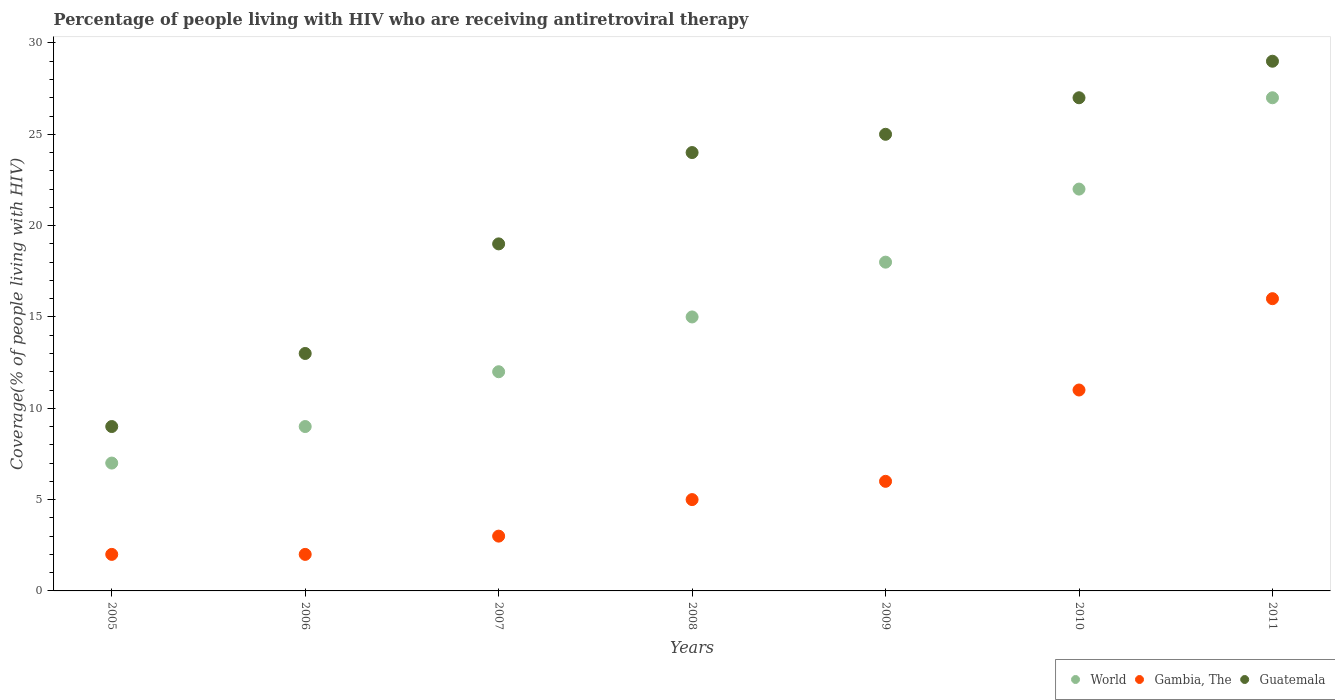How many different coloured dotlines are there?
Ensure brevity in your answer.  3. What is the percentage of the HIV infected people who are receiving antiretroviral therapy in Guatemala in 2011?
Your answer should be very brief. 29. Across all years, what is the maximum percentage of the HIV infected people who are receiving antiretroviral therapy in Gambia, The?
Give a very brief answer. 16. Across all years, what is the minimum percentage of the HIV infected people who are receiving antiretroviral therapy in Gambia, The?
Offer a very short reply. 2. What is the total percentage of the HIV infected people who are receiving antiretroviral therapy in Gambia, The in the graph?
Provide a succinct answer. 45. What is the difference between the percentage of the HIV infected people who are receiving antiretroviral therapy in Gambia, The in 2009 and that in 2011?
Offer a terse response. -10. What is the difference between the percentage of the HIV infected people who are receiving antiretroviral therapy in World in 2007 and the percentage of the HIV infected people who are receiving antiretroviral therapy in Guatemala in 2010?
Your response must be concise. -15. What is the average percentage of the HIV infected people who are receiving antiretroviral therapy in World per year?
Provide a succinct answer. 15.71. In the year 2009, what is the difference between the percentage of the HIV infected people who are receiving antiretroviral therapy in Gambia, The and percentage of the HIV infected people who are receiving antiretroviral therapy in Guatemala?
Offer a terse response. -19. Is the percentage of the HIV infected people who are receiving antiretroviral therapy in Guatemala in 2005 less than that in 2006?
Your answer should be very brief. Yes. What is the difference between the highest and the second highest percentage of the HIV infected people who are receiving antiretroviral therapy in World?
Provide a short and direct response. 5. What is the difference between the highest and the lowest percentage of the HIV infected people who are receiving antiretroviral therapy in World?
Offer a terse response. 20. In how many years, is the percentage of the HIV infected people who are receiving antiretroviral therapy in World greater than the average percentage of the HIV infected people who are receiving antiretroviral therapy in World taken over all years?
Provide a short and direct response. 3. How many dotlines are there?
Give a very brief answer. 3. What is the difference between two consecutive major ticks on the Y-axis?
Your response must be concise. 5. Does the graph contain any zero values?
Your answer should be compact. No. Does the graph contain grids?
Your response must be concise. No. Where does the legend appear in the graph?
Offer a terse response. Bottom right. What is the title of the graph?
Your response must be concise. Percentage of people living with HIV who are receiving antiretroviral therapy. What is the label or title of the Y-axis?
Offer a terse response. Coverage(% of people living with HIV). What is the Coverage(% of people living with HIV) in Gambia, The in 2005?
Give a very brief answer. 2. What is the Coverage(% of people living with HIV) in World in 2007?
Offer a terse response. 12. What is the Coverage(% of people living with HIV) in Gambia, The in 2007?
Provide a short and direct response. 3. What is the Coverage(% of people living with HIV) of Gambia, The in 2008?
Keep it short and to the point. 5. What is the Coverage(% of people living with HIV) of Gambia, The in 2009?
Provide a succinct answer. 6. What is the Coverage(% of people living with HIV) in Guatemala in 2009?
Your answer should be compact. 25. What is the Coverage(% of people living with HIV) of World in 2011?
Ensure brevity in your answer.  27. What is the Coverage(% of people living with HIV) of Guatemala in 2011?
Keep it short and to the point. 29. Across all years, what is the maximum Coverage(% of people living with HIV) in World?
Your answer should be very brief. 27. Across all years, what is the minimum Coverage(% of people living with HIV) in World?
Make the answer very short. 7. What is the total Coverage(% of people living with HIV) of World in the graph?
Make the answer very short. 110. What is the total Coverage(% of people living with HIV) of Gambia, The in the graph?
Give a very brief answer. 45. What is the total Coverage(% of people living with HIV) in Guatemala in the graph?
Your response must be concise. 146. What is the difference between the Coverage(% of people living with HIV) of Guatemala in 2005 and that in 2007?
Offer a very short reply. -10. What is the difference between the Coverage(% of people living with HIV) of World in 2005 and that in 2008?
Ensure brevity in your answer.  -8. What is the difference between the Coverage(% of people living with HIV) of Guatemala in 2005 and that in 2008?
Ensure brevity in your answer.  -15. What is the difference between the Coverage(% of people living with HIV) in World in 2005 and that in 2009?
Provide a short and direct response. -11. What is the difference between the Coverage(% of people living with HIV) of Gambia, The in 2005 and that in 2009?
Ensure brevity in your answer.  -4. What is the difference between the Coverage(% of people living with HIV) in Guatemala in 2005 and that in 2009?
Your answer should be very brief. -16. What is the difference between the Coverage(% of people living with HIV) in Guatemala in 2005 and that in 2011?
Your response must be concise. -20. What is the difference between the Coverage(% of people living with HIV) in Gambia, The in 2006 and that in 2007?
Your response must be concise. -1. What is the difference between the Coverage(% of people living with HIV) in Guatemala in 2006 and that in 2007?
Make the answer very short. -6. What is the difference between the Coverage(% of people living with HIV) in World in 2006 and that in 2008?
Keep it short and to the point. -6. What is the difference between the Coverage(% of people living with HIV) of Gambia, The in 2006 and that in 2008?
Offer a very short reply. -3. What is the difference between the Coverage(% of people living with HIV) in World in 2006 and that in 2009?
Provide a short and direct response. -9. What is the difference between the Coverage(% of people living with HIV) of Gambia, The in 2006 and that in 2009?
Make the answer very short. -4. What is the difference between the Coverage(% of people living with HIV) of Gambia, The in 2006 and that in 2010?
Your answer should be very brief. -9. What is the difference between the Coverage(% of people living with HIV) in Guatemala in 2006 and that in 2010?
Keep it short and to the point. -14. What is the difference between the Coverage(% of people living with HIV) in Guatemala in 2007 and that in 2008?
Ensure brevity in your answer.  -5. What is the difference between the Coverage(% of people living with HIV) in Gambia, The in 2007 and that in 2009?
Provide a succinct answer. -3. What is the difference between the Coverage(% of people living with HIV) in Guatemala in 2007 and that in 2009?
Offer a terse response. -6. What is the difference between the Coverage(% of people living with HIV) in Gambia, The in 2007 and that in 2010?
Your answer should be very brief. -8. What is the difference between the Coverage(% of people living with HIV) in World in 2007 and that in 2011?
Provide a short and direct response. -15. What is the difference between the Coverage(% of people living with HIV) in World in 2008 and that in 2010?
Offer a very short reply. -7. What is the difference between the Coverage(% of people living with HIV) of Gambia, The in 2008 and that in 2010?
Give a very brief answer. -6. What is the difference between the Coverage(% of people living with HIV) in Guatemala in 2008 and that in 2010?
Give a very brief answer. -3. What is the difference between the Coverage(% of people living with HIV) of Gambia, The in 2009 and that in 2010?
Give a very brief answer. -5. What is the difference between the Coverage(% of people living with HIV) of Guatemala in 2009 and that in 2010?
Give a very brief answer. -2. What is the difference between the Coverage(% of people living with HIV) of World in 2010 and that in 2011?
Offer a very short reply. -5. What is the difference between the Coverage(% of people living with HIV) of World in 2005 and the Coverage(% of people living with HIV) of Gambia, The in 2006?
Offer a terse response. 5. What is the difference between the Coverage(% of people living with HIV) in Gambia, The in 2005 and the Coverage(% of people living with HIV) in Guatemala in 2006?
Make the answer very short. -11. What is the difference between the Coverage(% of people living with HIV) in World in 2005 and the Coverage(% of people living with HIV) in Guatemala in 2007?
Offer a terse response. -12. What is the difference between the Coverage(% of people living with HIV) in Gambia, The in 2005 and the Coverage(% of people living with HIV) in Guatemala in 2007?
Make the answer very short. -17. What is the difference between the Coverage(% of people living with HIV) in World in 2005 and the Coverage(% of people living with HIV) in Gambia, The in 2008?
Keep it short and to the point. 2. What is the difference between the Coverage(% of people living with HIV) in World in 2005 and the Coverage(% of people living with HIV) in Gambia, The in 2009?
Your answer should be compact. 1. What is the difference between the Coverage(% of people living with HIV) of World in 2005 and the Coverage(% of people living with HIV) of Guatemala in 2009?
Your answer should be compact. -18. What is the difference between the Coverage(% of people living with HIV) of Gambia, The in 2005 and the Coverage(% of people living with HIV) of Guatemala in 2009?
Provide a short and direct response. -23. What is the difference between the Coverage(% of people living with HIV) in World in 2005 and the Coverage(% of people living with HIV) in Guatemala in 2010?
Your response must be concise. -20. What is the difference between the Coverage(% of people living with HIV) in World in 2005 and the Coverage(% of people living with HIV) in Gambia, The in 2011?
Your response must be concise. -9. What is the difference between the Coverage(% of people living with HIV) in World in 2005 and the Coverage(% of people living with HIV) in Guatemala in 2011?
Offer a very short reply. -22. What is the difference between the Coverage(% of people living with HIV) in World in 2006 and the Coverage(% of people living with HIV) in Gambia, The in 2007?
Your answer should be compact. 6. What is the difference between the Coverage(% of people living with HIV) in World in 2006 and the Coverage(% of people living with HIV) in Guatemala in 2007?
Give a very brief answer. -10. What is the difference between the Coverage(% of people living with HIV) in Gambia, The in 2006 and the Coverage(% of people living with HIV) in Guatemala in 2008?
Give a very brief answer. -22. What is the difference between the Coverage(% of people living with HIV) in World in 2006 and the Coverage(% of people living with HIV) in Guatemala in 2009?
Your answer should be compact. -16. What is the difference between the Coverage(% of people living with HIV) of World in 2006 and the Coverage(% of people living with HIV) of Gambia, The in 2010?
Offer a terse response. -2. What is the difference between the Coverage(% of people living with HIV) of World in 2006 and the Coverage(% of people living with HIV) of Gambia, The in 2011?
Ensure brevity in your answer.  -7. What is the difference between the Coverage(% of people living with HIV) of World in 2006 and the Coverage(% of people living with HIV) of Guatemala in 2011?
Your answer should be compact. -20. What is the difference between the Coverage(% of people living with HIV) of Gambia, The in 2006 and the Coverage(% of people living with HIV) of Guatemala in 2011?
Make the answer very short. -27. What is the difference between the Coverage(% of people living with HIV) of World in 2007 and the Coverage(% of people living with HIV) of Gambia, The in 2008?
Give a very brief answer. 7. What is the difference between the Coverage(% of people living with HIV) in World in 2007 and the Coverage(% of people living with HIV) in Guatemala in 2008?
Your answer should be compact. -12. What is the difference between the Coverage(% of people living with HIV) in World in 2007 and the Coverage(% of people living with HIV) in Gambia, The in 2009?
Ensure brevity in your answer.  6. What is the difference between the Coverage(% of people living with HIV) of World in 2007 and the Coverage(% of people living with HIV) of Guatemala in 2010?
Provide a short and direct response. -15. What is the difference between the Coverage(% of people living with HIV) in Gambia, The in 2007 and the Coverage(% of people living with HIV) in Guatemala in 2010?
Your response must be concise. -24. What is the difference between the Coverage(% of people living with HIV) of World in 2007 and the Coverage(% of people living with HIV) of Gambia, The in 2011?
Provide a succinct answer. -4. What is the difference between the Coverage(% of people living with HIV) in World in 2007 and the Coverage(% of people living with HIV) in Guatemala in 2011?
Offer a terse response. -17. What is the difference between the Coverage(% of people living with HIV) in World in 2008 and the Coverage(% of people living with HIV) in Guatemala in 2009?
Offer a terse response. -10. What is the difference between the Coverage(% of people living with HIV) in Gambia, The in 2008 and the Coverage(% of people living with HIV) in Guatemala in 2009?
Your answer should be compact. -20. What is the difference between the Coverage(% of people living with HIV) of World in 2008 and the Coverage(% of people living with HIV) of Gambia, The in 2010?
Make the answer very short. 4. What is the difference between the Coverage(% of people living with HIV) in World in 2008 and the Coverage(% of people living with HIV) in Guatemala in 2010?
Keep it short and to the point. -12. What is the difference between the Coverage(% of people living with HIV) in Gambia, The in 2008 and the Coverage(% of people living with HIV) in Guatemala in 2010?
Make the answer very short. -22. What is the difference between the Coverage(% of people living with HIV) of World in 2008 and the Coverage(% of people living with HIV) of Gambia, The in 2011?
Keep it short and to the point. -1. What is the difference between the Coverage(% of people living with HIV) in Gambia, The in 2008 and the Coverage(% of people living with HIV) in Guatemala in 2011?
Your answer should be very brief. -24. What is the difference between the Coverage(% of people living with HIV) in World in 2009 and the Coverage(% of people living with HIV) in Gambia, The in 2010?
Offer a terse response. 7. What is the difference between the Coverage(% of people living with HIV) in World in 2009 and the Coverage(% of people living with HIV) in Guatemala in 2010?
Provide a succinct answer. -9. What is the difference between the Coverage(% of people living with HIV) of World in 2009 and the Coverage(% of people living with HIV) of Guatemala in 2011?
Your answer should be compact. -11. What is the difference between the Coverage(% of people living with HIV) of Gambia, The in 2009 and the Coverage(% of people living with HIV) of Guatemala in 2011?
Ensure brevity in your answer.  -23. What is the difference between the Coverage(% of people living with HIV) of World in 2010 and the Coverage(% of people living with HIV) of Guatemala in 2011?
Offer a terse response. -7. What is the difference between the Coverage(% of people living with HIV) in Gambia, The in 2010 and the Coverage(% of people living with HIV) in Guatemala in 2011?
Your response must be concise. -18. What is the average Coverage(% of people living with HIV) of World per year?
Your answer should be very brief. 15.71. What is the average Coverage(% of people living with HIV) of Gambia, The per year?
Your answer should be very brief. 6.43. What is the average Coverage(% of people living with HIV) in Guatemala per year?
Your answer should be very brief. 20.86. In the year 2005, what is the difference between the Coverage(% of people living with HIV) in World and Coverage(% of people living with HIV) in Guatemala?
Give a very brief answer. -2. In the year 2006, what is the difference between the Coverage(% of people living with HIV) of World and Coverage(% of people living with HIV) of Gambia, The?
Make the answer very short. 7. In the year 2006, what is the difference between the Coverage(% of people living with HIV) in World and Coverage(% of people living with HIV) in Guatemala?
Your response must be concise. -4. In the year 2007, what is the difference between the Coverage(% of people living with HIV) of World and Coverage(% of people living with HIV) of Guatemala?
Your response must be concise. -7. In the year 2007, what is the difference between the Coverage(% of people living with HIV) in Gambia, The and Coverage(% of people living with HIV) in Guatemala?
Give a very brief answer. -16. In the year 2008, what is the difference between the Coverage(% of people living with HIV) in Gambia, The and Coverage(% of people living with HIV) in Guatemala?
Provide a succinct answer. -19. In the year 2009, what is the difference between the Coverage(% of people living with HIV) of World and Coverage(% of people living with HIV) of Guatemala?
Ensure brevity in your answer.  -7. In the year 2009, what is the difference between the Coverage(% of people living with HIV) in Gambia, The and Coverage(% of people living with HIV) in Guatemala?
Offer a very short reply. -19. In the year 2010, what is the difference between the Coverage(% of people living with HIV) in Gambia, The and Coverage(% of people living with HIV) in Guatemala?
Your response must be concise. -16. In the year 2011, what is the difference between the Coverage(% of people living with HIV) of World and Coverage(% of people living with HIV) of Guatemala?
Your answer should be compact. -2. What is the ratio of the Coverage(% of people living with HIV) of Guatemala in 2005 to that in 2006?
Provide a succinct answer. 0.69. What is the ratio of the Coverage(% of people living with HIV) in World in 2005 to that in 2007?
Your answer should be compact. 0.58. What is the ratio of the Coverage(% of people living with HIV) of Guatemala in 2005 to that in 2007?
Your answer should be compact. 0.47. What is the ratio of the Coverage(% of people living with HIV) of World in 2005 to that in 2008?
Your answer should be compact. 0.47. What is the ratio of the Coverage(% of people living with HIV) in Gambia, The in 2005 to that in 2008?
Offer a very short reply. 0.4. What is the ratio of the Coverage(% of people living with HIV) of Guatemala in 2005 to that in 2008?
Make the answer very short. 0.38. What is the ratio of the Coverage(% of people living with HIV) in World in 2005 to that in 2009?
Give a very brief answer. 0.39. What is the ratio of the Coverage(% of people living with HIV) of Gambia, The in 2005 to that in 2009?
Offer a very short reply. 0.33. What is the ratio of the Coverage(% of people living with HIV) of Guatemala in 2005 to that in 2009?
Your answer should be very brief. 0.36. What is the ratio of the Coverage(% of people living with HIV) in World in 2005 to that in 2010?
Your answer should be very brief. 0.32. What is the ratio of the Coverage(% of people living with HIV) in Gambia, The in 2005 to that in 2010?
Give a very brief answer. 0.18. What is the ratio of the Coverage(% of people living with HIV) in World in 2005 to that in 2011?
Provide a short and direct response. 0.26. What is the ratio of the Coverage(% of people living with HIV) of Gambia, The in 2005 to that in 2011?
Your answer should be compact. 0.12. What is the ratio of the Coverage(% of people living with HIV) of Guatemala in 2005 to that in 2011?
Keep it short and to the point. 0.31. What is the ratio of the Coverage(% of people living with HIV) of World in 2006 to that in 2007?
Your answer should be very brief. 0.75. What is the ratio of the Coverage(% of people living with HIV) in Guatemala in 2006 to that in 2007?
Your response must be concise. 0.68. What is the ratio of the Coverage(% of people living with HIV) in World in 2006 to that in 2008?
Give a very brief answer. 0.6. What is the ratio of the Coverage(% of people living with HIV) in Gambia, The in 2006 to that in 2008?
Offer a very short reply. 0.4. What is the ratio of the Coverage(% of people living with HIV) in Guatemala in 2006 to that in 2008?
Offer a very short reply. 0.54. What is the ratio of the Coverage(% of people living with HIV) in Gambia, The in 2006 to that in 2009?
Provide a succinct answer. 0.33. What is the ratio of the Coverage(% of people living with HIV) in Guatemala in 2006 to that in 2009?
Offer a very short reply. 0.52. What is the ratio of the Coverage(% of people living with HIV) in World in 2006 to that in 2010?
Offer a very short reply. 0.41. What is the ratio of the Coverage(% of people living with HIV) of Gambia, The in 2006 to that in 2010?
Your response must be concise. 0.18. What is the ratio of the Coverage(% of people living with HIV) in Guatemala in 2006 to that in 2010?
Offer a very short reply. 0.48. What is the ratio of the Coverage(% of people living with HIV) in World in 2006 to that in 2011?
Give a very brief answer. 0.33. What is the ratio of the Coverage(% of people living with HIV) of Gambia, The in 2006 to that in 2011?
Make the answer very short. 0.12. What is the ratio of the Coverage(% of people living with HIV) in Guatemala in 2006 to that in 2011?
Keep it short and to the point. 0.45. What is the ratio of the Coverage(% of people living with HIV) of World in 2007 to that in 2008?
Your answer should be very brief. 0.8. What is the ratio of the Coverage(% of people living with HIV) of Guatemala in 2007 to that in 2008?
Keep it short and to the point. 0.79. What is the ratio of the Coverage(% of people living with HIV) of World in 2007 to that in 2009?
Make the answer very short. 0.67. What is the ratio of the Coverage(% of people living with HIV) in Guatemala in 2007 to that in 2009?
Your answer should be very brief. 0.76. What is the ratio of the Coverage(% of people living with HIV) of World in 2007 to that in 2010?
Offer a terse response. 0.55. What is the ratio of the Coverage(% of people living with HIV) of Gambia, The in 2007 to that in 2010?
Provide a succinct answer. 0.27. What is the ratio of the Coverage(% of people living with HIV) in Guatemala in 2007 to that in 2010?
Keep it short and to the point. 0.7. What is the ratio of the Coverage(% of people living with HIV) in World in 2007 to that in 2011?
Keep it short and to the point. 0.44. What is the ratio of the Coverage(% of people living with HIV) of Gambia, The in 2007 to that in 2011?
Provide a short and direct response. 0.19. What is the ratio of the Coverage(% of people living with HIV) in Guatemala in 2007 to that in 2011?
Your answer should be very brief. 0.66. What is the ratio of the Coverage(% of people living with HIV) in Gambia, The in 2008 to that in 2009?
Provide a short and direct response. 0.83. What is the ratio of the Coverage(% of people living with HIV) of Guatemala in 2008 to that in 2009?
Your answer should be very brief. 0.96. What is the ratio of the Coverage(% of people living with HIV) of World in 2008 to that in 2010?
Give a very brief answer. 0.68. What is the ratio of the Coverage(% of people living with HIV) of Gambia, The in 2008 to that in 2010?
Your answer should be compact. 0.45. What is the ratio of the Coverage(% of people living with HIV) in World in 2008 to that in 2011?
Your answer should be very brief. 0.56. What is the ratio of the Coverage(% of people living with HIV) in Gambia, The in 2008 to that in 2011?
Your answer should be very brief. 0.31. What is the ratio of the Coverage(% of people living with HIV) of Guatemala in 2008 to that in 2011?
Your answer should be compact. 0.83. What is the ratio of the Coverage(% of people living with HIV) of World in 2009 to that in 2010?
Make the answer very short. 0.82. What is the ratio of the Coverage(% of people living with HIV) of Gambia, The in 2009 to that in 2010?
Make the answer very short. 0.55. What is the ratio of the Coverage(% of people living with HIV) of Guatemala in 2009 to that in 2010?
Provide a short and direct response. 0.93. What is the ratio of the Coverage(% of people living with HIV) in World in 2009 to that in 2011?
Ensure brevity in your answer.  0.67. What is the ratio of the Coverage(% of people living with HIV) of Guatemala in 2009 to that in 2011?
Offer a very short reply. 0.86. What is the ratio of the Coverage(% of people living with HIV) of World in 2010 to that in 2011?
Provide a short and direct response. 0.81. What is the ratio of the Coverage(% of people living with HIV) of Gambia, The in 2010 to that in 2011?
Provide a short and direct response. 0.69. What is the difference between the highest and the second highest Coverage(% of people living with HIV) in Gambia, The?
Keep it short and to the point. 5. What is the difference between the highest and the second highest Coverage(% of people living with HIV) in Guatemala?
Ensure brevity in your answer.  2. What is the difference between the highest and the lowest Coverage(% of people living with HIV) of World?
Make the answer very short. 20. What is the difference between the highest and the lowest Coverage(% of people living with HIV) of Guatemala?
Offer a terse response. 20. 